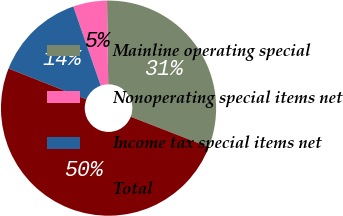Convert chart to OTSL. <chart><loc_0><loc_0><loc_500><loc_500><pie_chart><fcel>Mainline operating special<fcel>Nonoperating special items net<fcel>Income tax special items net<fcel>Total<nl><fcel>31.13%<fcel>5.09%<fcel>13.68%<fcel>50.1%<nl></chart> 